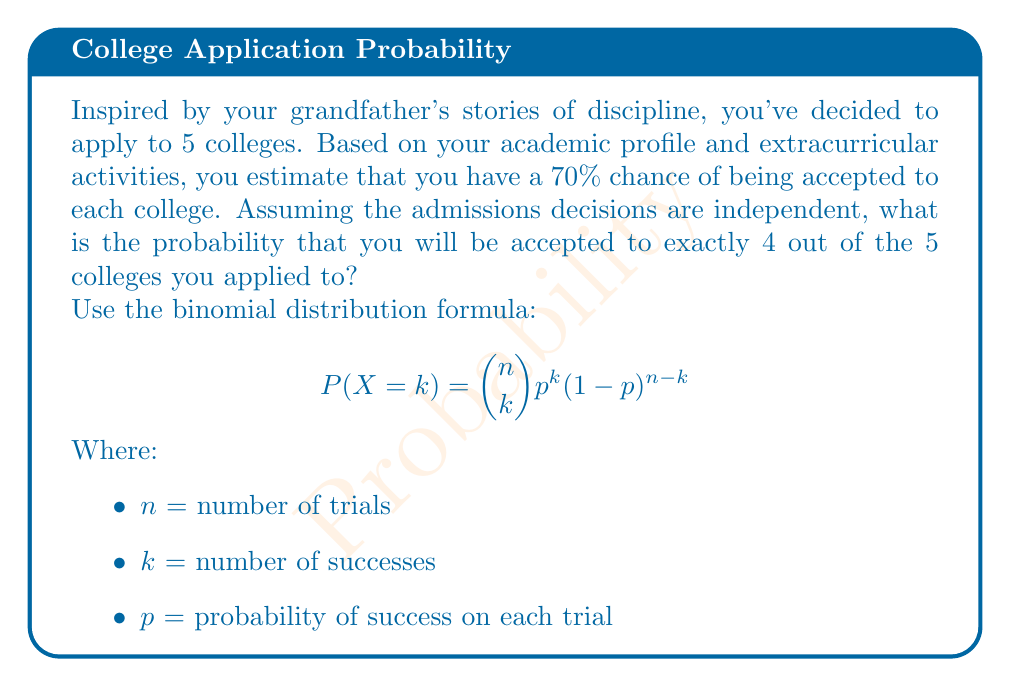Help me with this question. Let's approach this step-by-step:

1) We are using the binomial distribution because:
   - There is a fixed number of trials (5 college applications)
   - Each trial has two possible outcomes (accepted or rejected)
   - The probability of success (p) is the same for each trial (70% or 0.70)
   - The trials are independent

2) We need to calculate $P(X = 4)$ where:
   $n = 5$ (total number of colleges)
   $k = 4$ (number of acceptances we're interested in)
   $p = 0.70$ (probability of acceptance for each college)

3) Let's substitute these values into the formula:

   $$P(X = 4) = \binom{5}{4} (0.70)^4 (1-0.70)^{5-4}$$

4) Calculate the binomial coefficient:
   $$\binom{5}{4} = \frac{5!}{4!(5-4)!} = \frac{5!}{4!1!} = 5$$

5) Substitute this value:
   $$P(X = 4) = 5 \cdot (0.70)^4 \cdot (0.30)^1$$

6) Calculate the powers:
   $$P(X = 4) = 5 \cdot 0.2401 \cdot 0.30$$

7) Multiply:
   $$P(X = 4) = 0.36015$$

8) Round to 4 decimal places:
   $$P(X = 4) \approx 0.3602$$
Answer: 0.3602 